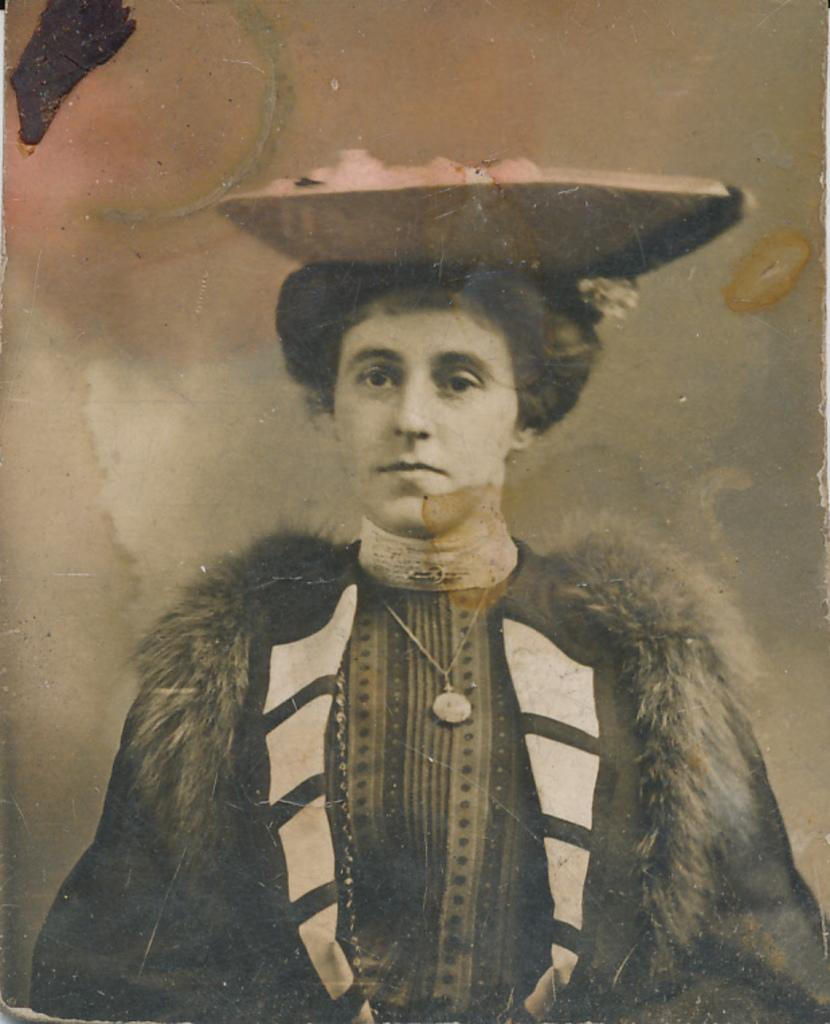What is the main subject of the image? There is a person in the image. Can you describe the person's attire? The person is wearing clothes. What is on the person's head? There is an object on the person's head. How many pumpkins are visible on the person's head in the image? There are no pumpkins visible on the person's head in the image. What type of person is depicted in the image? The type of person cannot be determined from the image alone, as it only shows a person with an object on their head and wearing clothes. 